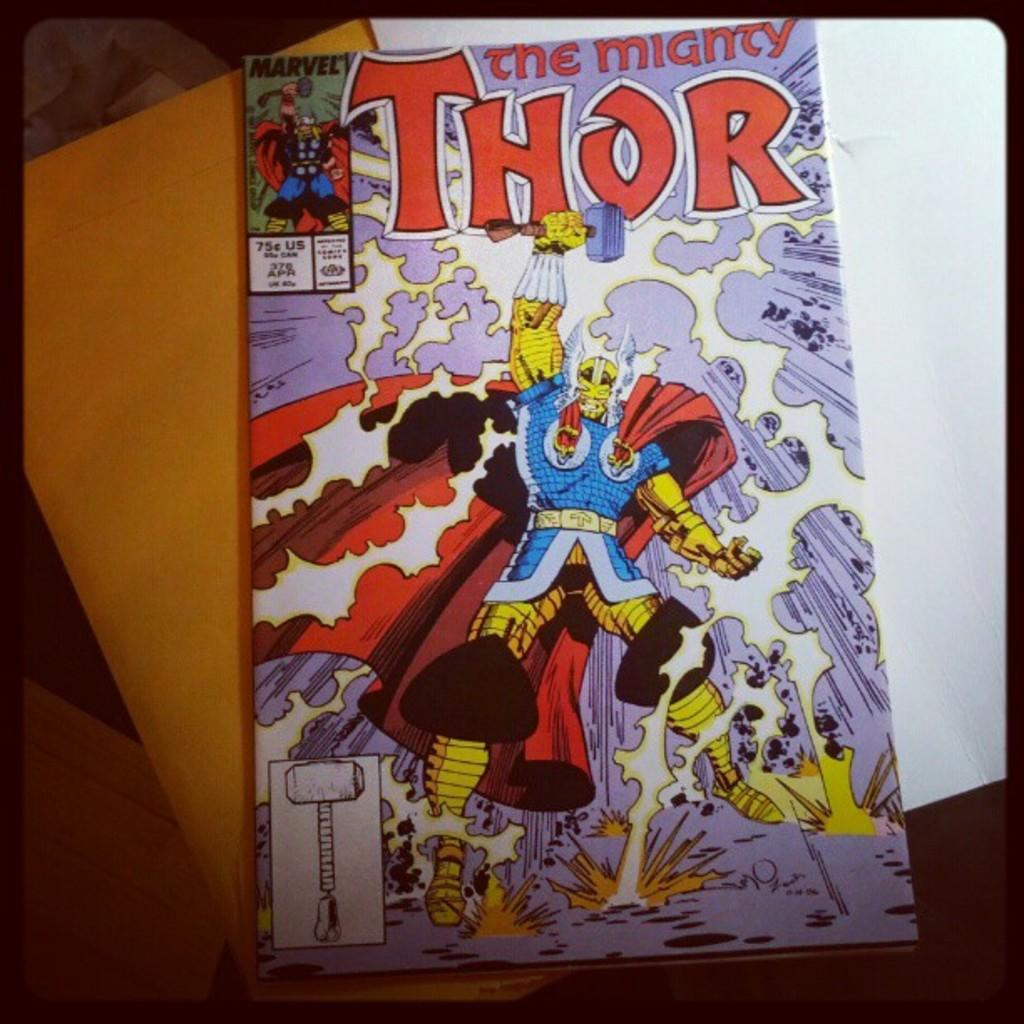<image>
Share a concise interpretation of the image provided. A "THOR the mighty" comic book with an illustration of Thor and his hammer upon the cover sits atop a manila envelope. 